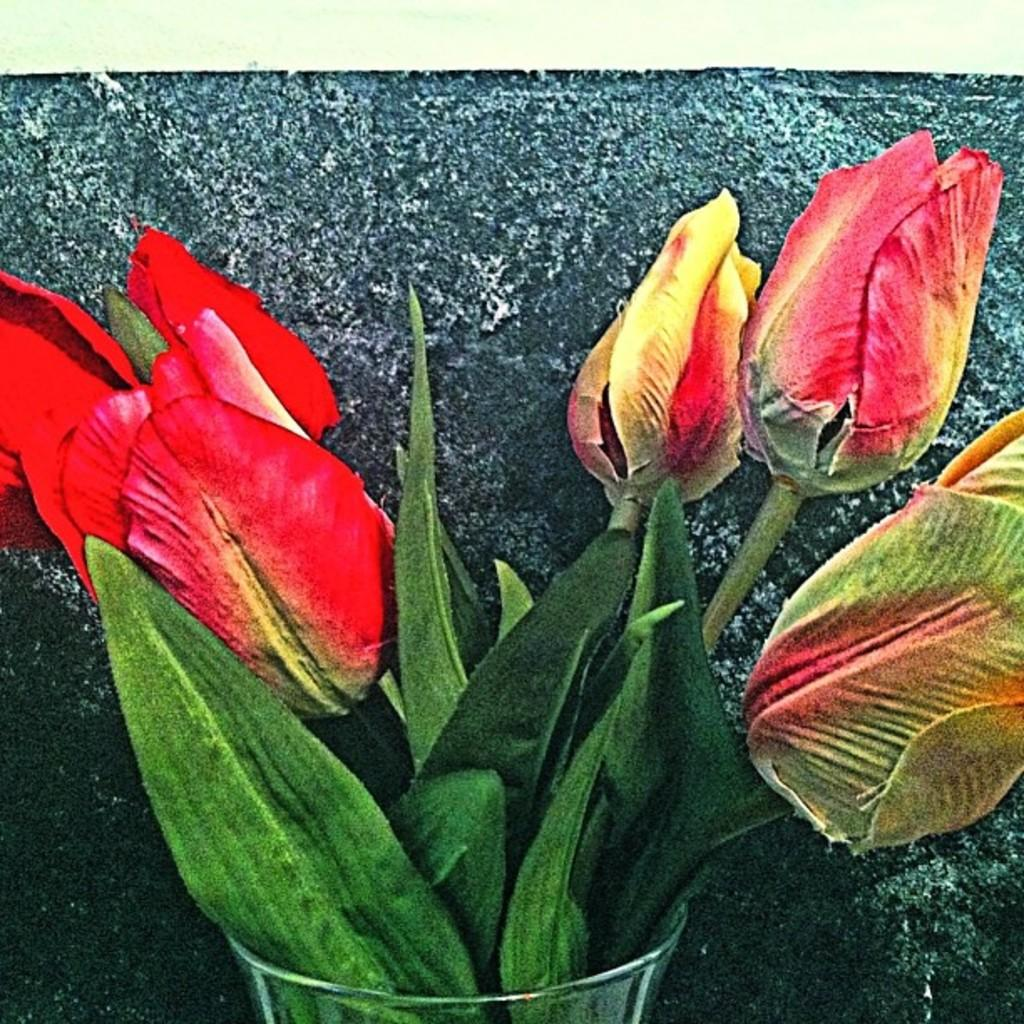What is contained within the object that resembles a glass in the image? There are flowers and leaves in the object that looks like a glass. What is the most likely type of object that is holding the flowers and leaves? The object is likely a glass. What can be seen in the background of the image? There is a wall in the background of the image. What type of guitar is being played by the beginner in the image? There is no guitar or beginner present in the image; it features a glass with flowers and leaves, and a wall in the background. 